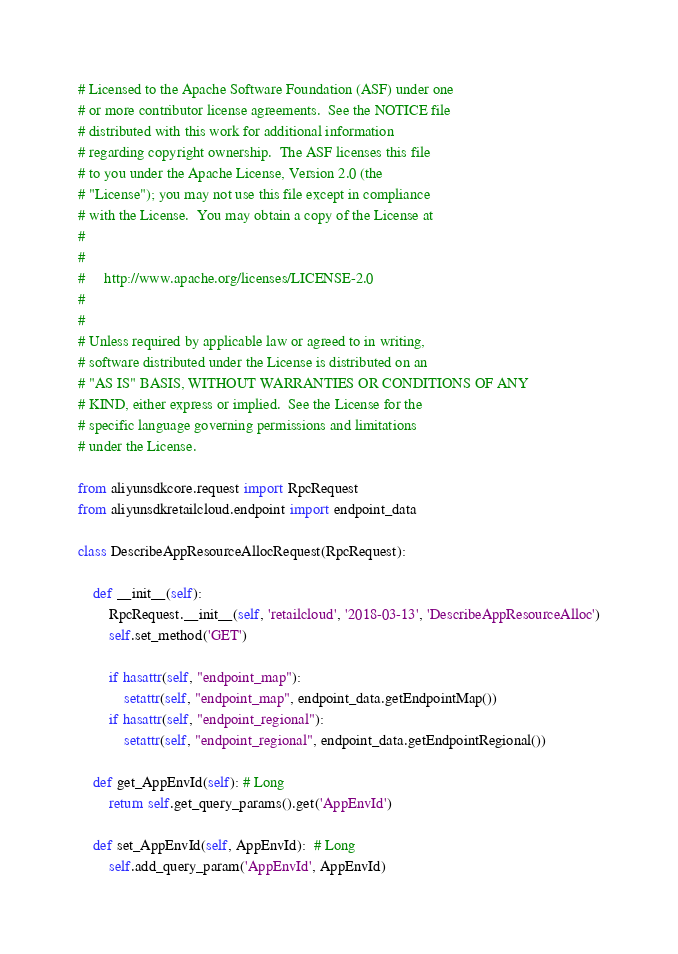Convert code to text. <code><loc_0><loc_0><loc_500><loc_500><_Python_># Licensed to the Apache Software Foundation (ASF) under one
# or more contributor license agreements.  See the NOTICE file
# distributed with this work for additional information
# regarding copyright ownership.  The ASF licenses this file
# to you under the Apache License, Version 2.0 (the
# "License"); you may not use this file except in compliance
# with the License.  You may obtain a copy of the License at
#
#
#     http://www.apache.org/licenses/LICENSE-2.0
#
#
# Unless required by applicable law or agreed to in writing,
# software distributed under the License is distributed on an
# "AS IS" BASIS, WITHOUT WARRANTIES OR CONDITIONS OF ANY
# KIND, either express or implied.  See the License for the
# specific language governing permissions and limitations
# under the License.

from aliyunsdkcore.request import RpcRequest
from aliyunsdkretailcloud.endpoint import endpoint_data

class DescribeAppResourceAllocRequest(RpcRequest):

	def __init__(self):
		RpcRequest.__init__(self, 'retailcloud', '2018-03-13', 'DescribeAppResourceAlloc')
		self.set_method('GET')

		if hasattr(self, "endpoint_map"):
			setattr(self, "endpoint_map", endpoint_data.getEndpointMap())
		if hasattr(self, "endpoint_regional"):
			setattr(self, "endpoint_regional", endpoint_data.getEndpointRegional())

	def get_AppEnvId(self): # Long
		return self.get_query_params().get('AppEnvId')

	def set_AppEnvId(self, AppEnvId):  # Long
		self.add_query_param('AppEnvId', AppEnvId)
</code> 